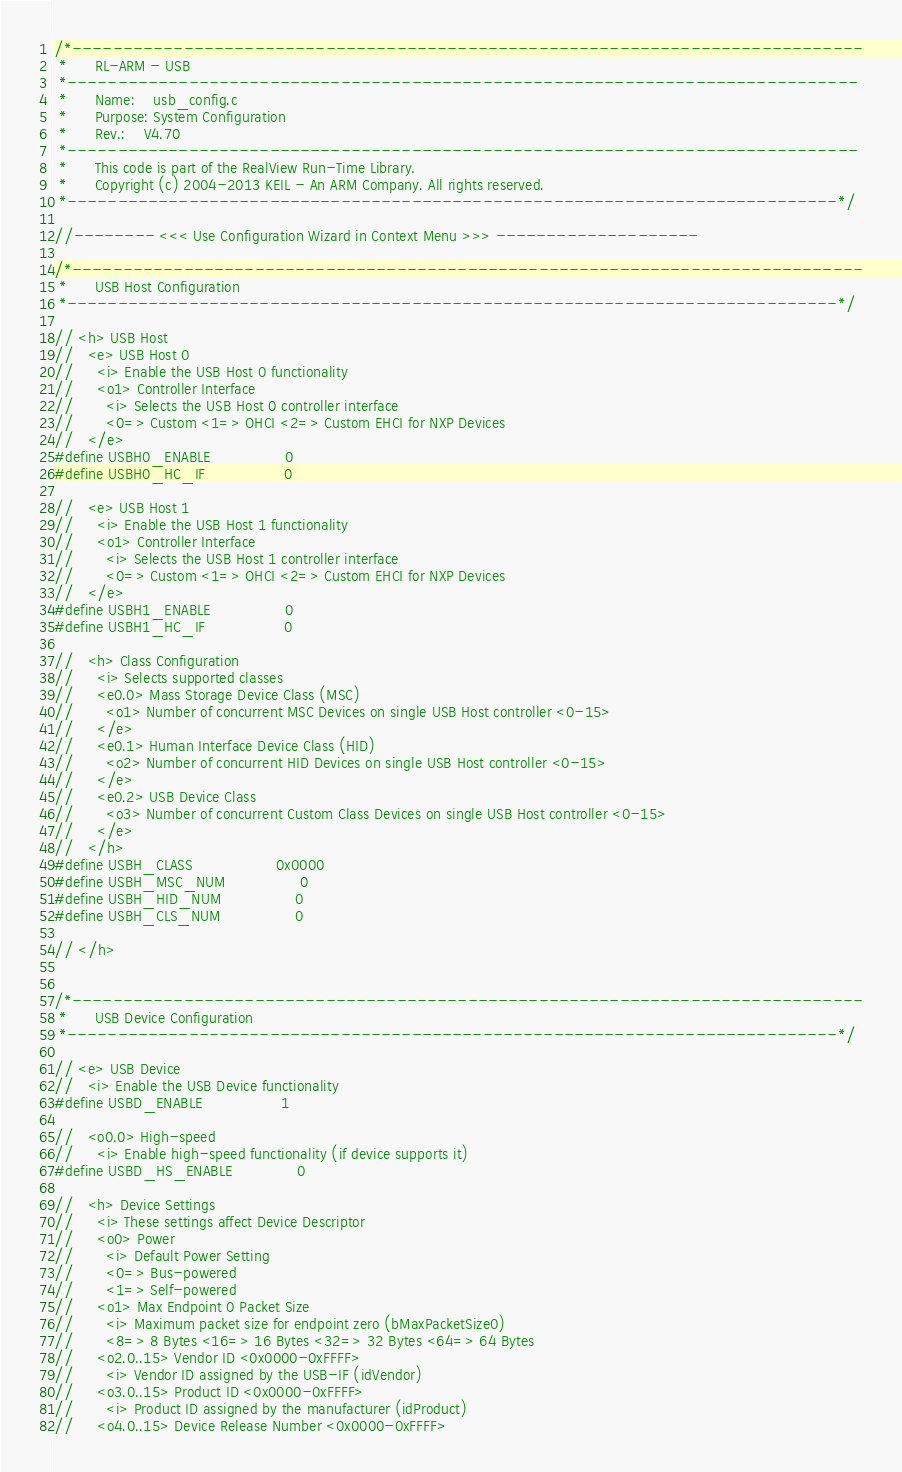Convert code to text. <code><loc_0><loc_0><loc_500><loc_500><_C_>/*------------------------------------------------------------------------------
 *      RL-ARM - USB
 *------------------------------------------------------------------------------
 *      Name:    usb_config.c
 *      Purpose: System Configuration
 *      Rev.:    V4.70
 *------------------------------------------------------------------------------
 *      This code is part of the RealView Run-Time Library.
 *      Copyright (c) 2004-2013 KEIL - An ARM Company. All rights reserved.
 *----------------------------------------------------------------------------*/

//-------- <<< Use Configuration Wizard in Context Menu >>> --------------------

/*------------------------------------------------------------------------------
 *      USB Host Configuration
 *----------------------------------------------------------------------------*/

// <h> USB Host
//   <e> USB Host 0
//     <i> Enable the USB Host 0 functionality
//     <o1> Controller Interface 
//       <i> Selects the USB Host 0 controller interface
//       <0=> Custom <1=> OHCI <2=> Custom EHCI for NXP Devices
//   </e>
#define USBH0_ENABLE                0
#define USBH0_HC_IF                 0

//   <e> USB Host 1
//     <i> Enable the USB Host 1 functionality
//     <o1> Controller Interface 
//       <i> Selects the USB Host 1 controller interface
//       <0=> Custom <1=> OHCI <2=> Custom EHCI for NXP Devices
//   </e>
#define USBH1_ENABLE                0
#define USBH1_HC_IF                 0

//   <h> Class Configuration
//     <i> Selects supported classes
//     <e0.0> Mass Storage Device Class (MSC)
//       <o1> Number of concurrent MSC Devices on single USB Host controller <0-15>
//     </e>
//     <e0.1> Human Interface Device Class (HID)
//       <o2> Number of concurrent HID Devices on single USB Host controller <0-15>
//     </e>
//     <e0.2> USB Device Class
//       <o3> Number of concurrent Custom Class Devices on single USB Host controller <0-15>
//     </e>
//   </h>
#define USBH_CLASS                  0x0000
#define USBH_MSC_NUM                0
#define USBH_HID_NUM                0
#define USBH_CLS_NUM                0

// </h>


/*------------------------------------------------------------------------------
 *      USB Device Configuration
 *----------------------------------------------------------------------------*/

// <e> USB Device
//   <i> Enable the USB Device functionality
#define USBD_ENABLE                 1

//   <o0.0> High-speed
//     <i> Enable high-speed functionality (if device supports it)
#define USBD_HS_ENABLE              0

//   <h> Device Settings
//     <i> These settings affect Device Descriptor
//     <o0> Power
//       <i> Default Power Setting
//       <0=> Bus-powered
//       <1=> Self-powered
//     <o1> Max Endpoint 0 Packet Size
//       <i> Maximum packet size for endpoint zero (bMaxPacketSize0)
//       <8=> 8 Bytes <16=> 16 Bytes <32=> 32 Bytes <64=> 64 Bytes
//     <o2.0..15> Vendor ID <0x0000-0xFFFF>
//       <i> Vendor ID assigned by the USB-IF (idVendor)
//     <o3.0..15> Product ID <0x0000-0xFFFF>
//       <i> Product ID assigned by the manufacturer (idProduct)
//     <o4.0..15> Device Release Number <0x0000-0xFFFF></code> 